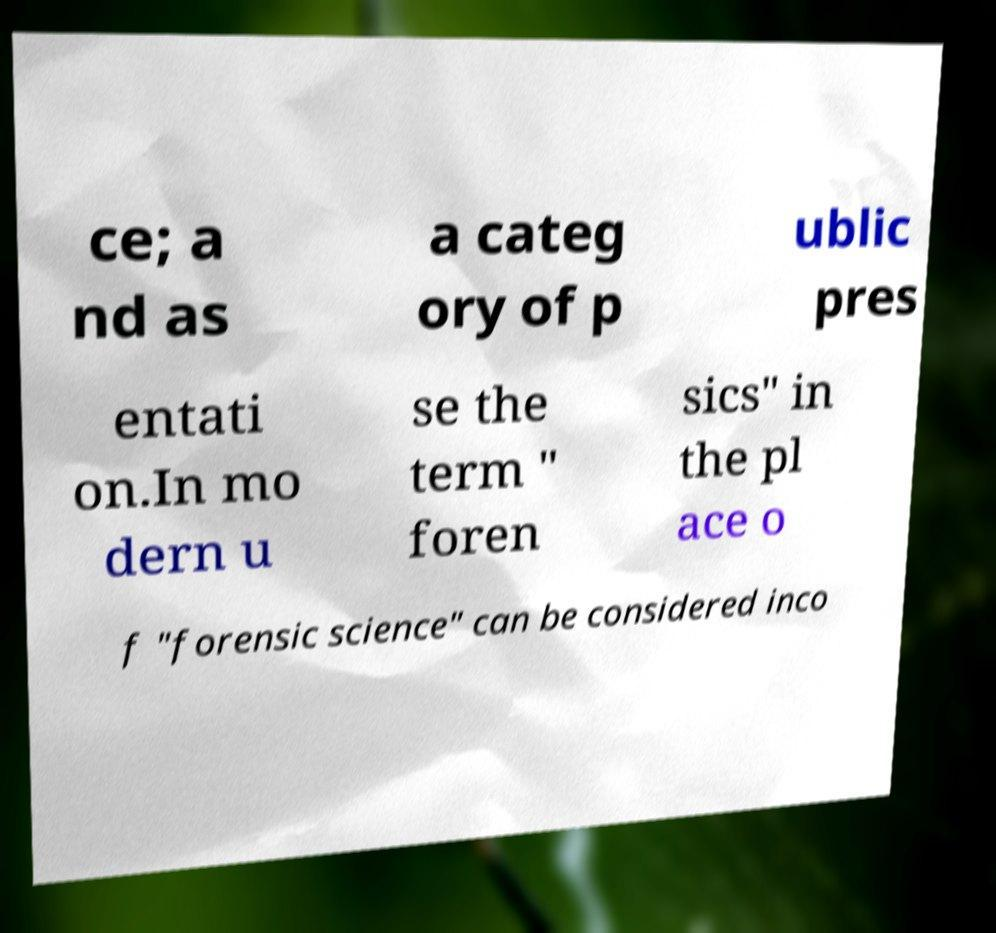What messages or text are displayed in this image? I need them in a readable, typed format. ce; a nd as a categ ory of p ublic pres entati on.In mo dern u se the term " foren sics" in the pl ace o f "forensic science" can be considered inco 